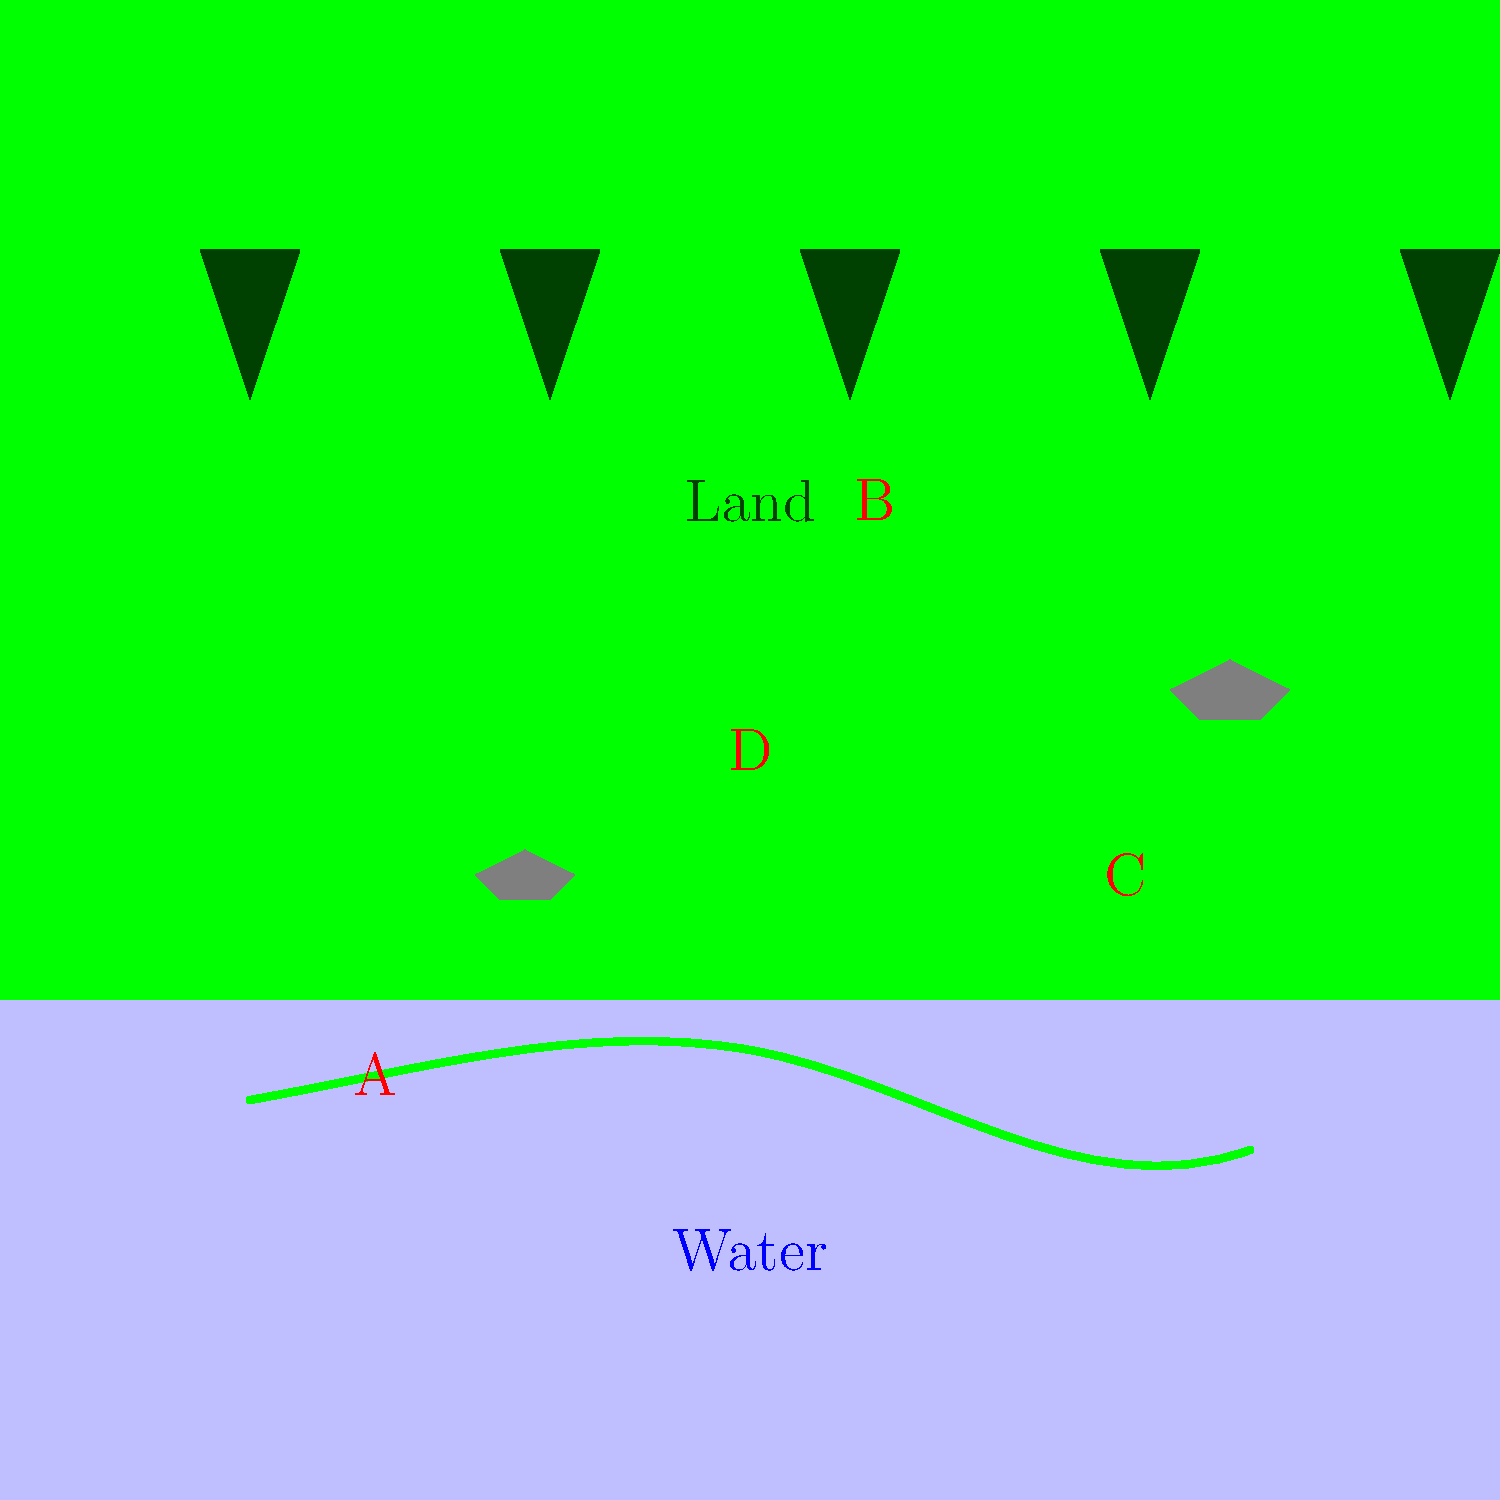In the diagram above, which labeled area represents the most crucial habitat feature for a Venezuelan anaconda's survival and hunting activities? To answer this question, let's analyze each labeled area in the context of a Venezuelan anaconda's habitat requirements:

1. Area A: This represents the water body, likely a river or swamp. Anacondas are semi-aquatic snakes that spend a significant portion of their time in or near water. Water is crucial for:
   - Thermoregulation (controlling body temperature)
   - Hunting aquatic prey
   - Escaping predators
   - Mating and giving birth

2. Area B: This shows the forested land area. While anacondas do venture onto land, it's not their primary habitat.

3. Area C: These are rocks near the water's edge. While they might provide basking spots, they are not as critical as the water itself.

4. Area D: This represents the transitional zone between water and land, which can be important for basking and ambush hunting, but it's not as vital as the water body itself.

Given these considerations, the most crucial habitat feature for a Venezuelan anaconda's survival and hunting activities is the water body (Area A). Anacondas are heavily dependent on aquatic environments for most of their life processes, making water the key feature of their habitat.
Answer: A (Water body) 